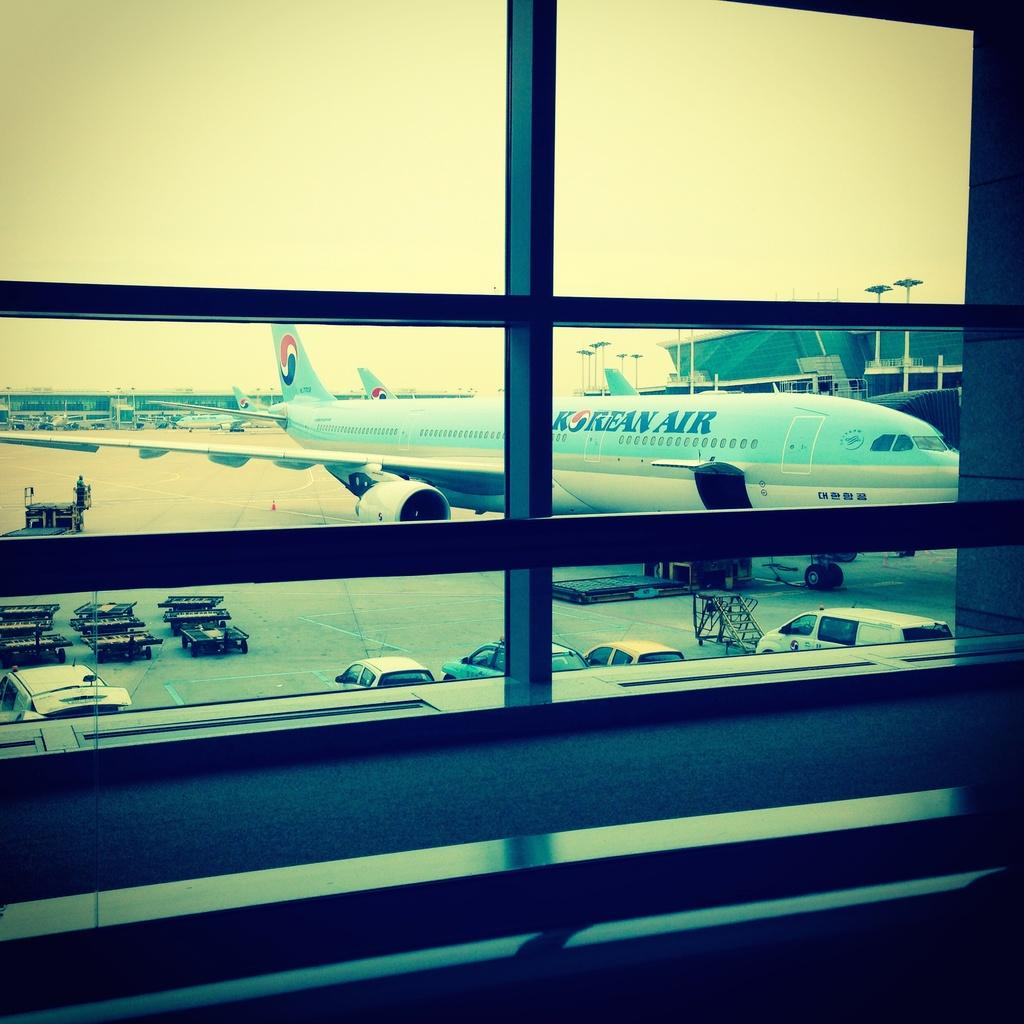<image>
Create a compact narrative representing the image presented. a korean air plane can be seen through the window 